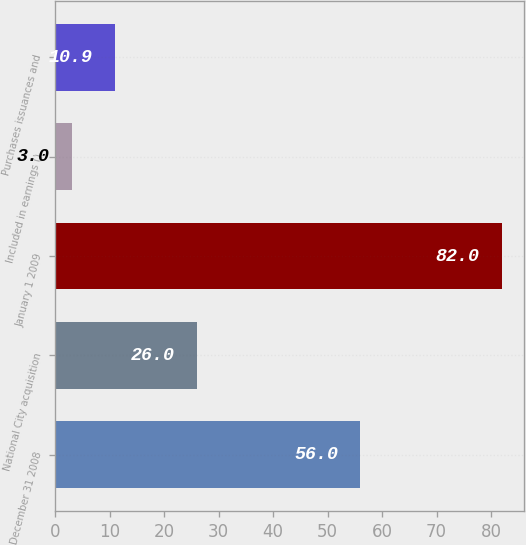Convert chart to OTSL. <chart><loc_0><loc_0><loc_500><loc_500><bar_chart><fcel>December 31 2008<fcel>National City acquisition<fcel>January 1 2009<fcel>Included in earnings ()<fcel>Purchases issuances and<nl><fcel>56<fcel>26<fcel>82<fcel>3<fcel>10.9<nl></chart> 